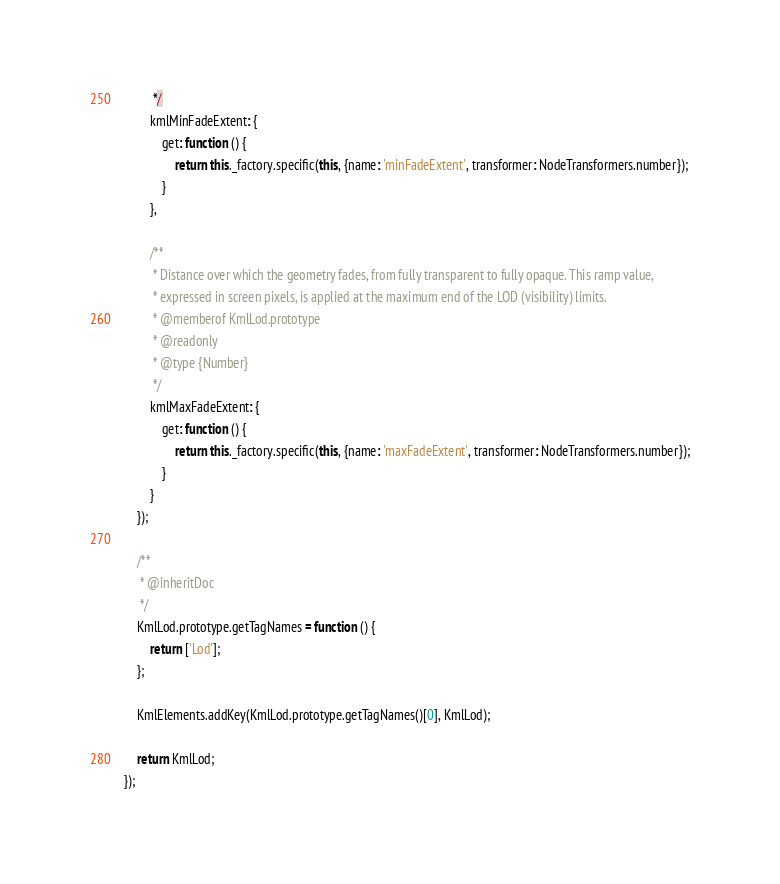<code> <loc_0><loc_0><loc_500><loc_500><_JavaScript_>         */
        kmlMinFadeExtent: {
            get: function () {
                return this._factory.specific(this, {name: 'minFadeExtent', transformer: NodeTransformers.number});
            }
        },

        /**
         * Distance over which the geometry fades, from fully transparent to fully opaque. This ramp value,
         * expressed in screen pixels, is applied at the maximum end of the LOD (visibility) limits.
         * @memberof KmlLod.prototype
         * @readonly
         * @type {Number}
         */
        kmlMaxFadeExtent: {
            get: function () {
                return this._factory.specific(this, {name: 'maxFadeExtent', transformer: NodeTransformers.number});
            }
        }
    });

    /**
     * @inheritDoc
     */
    KmlLod.prototype.getTagNames = function () {
        return ['Lod'];
    };

    KmlElements.addKey(KmlLod.prototype.getTagNames()[0], KmlLod);

    return KmlLod;
});</code> 